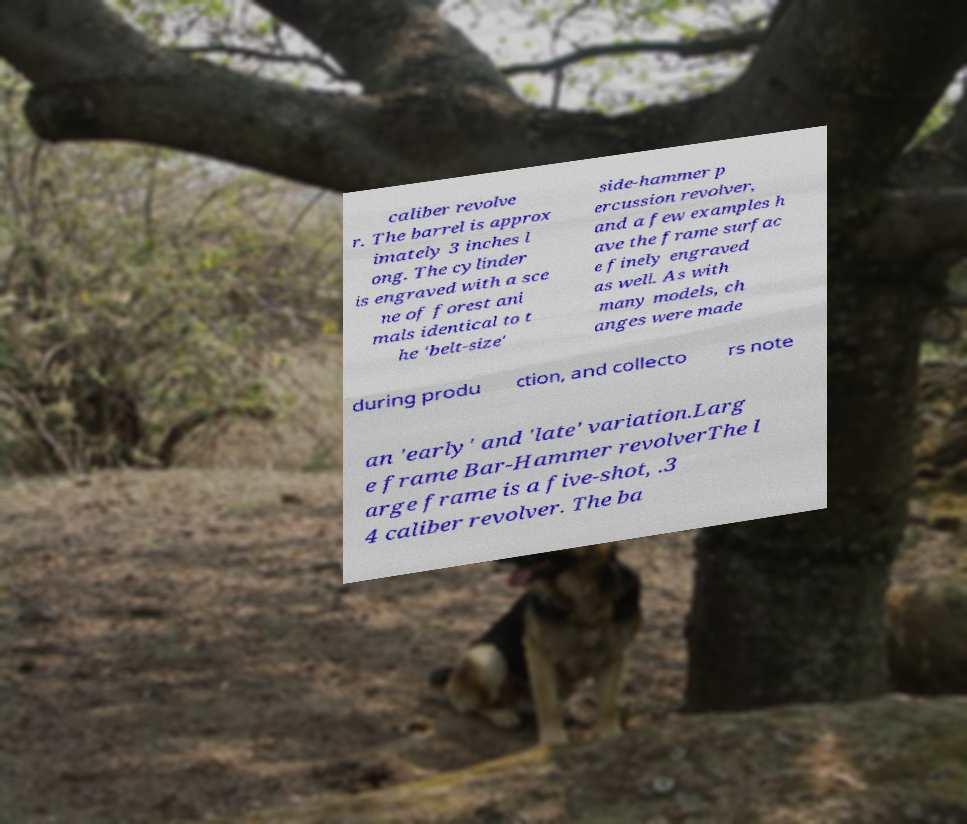Can you read and provide the text displayed in the image?This photo seems to have some interesting text. Can you extract and type it out for me? caliber revolve r. The barrel is approx imately 3 inches l ong. The cylinder is engraved with a sce ne of forest ani mals identical to t he 'belt-size' side-hammer p ercussion revolver, and a few examples h ave the frame surfac e finely engraved as well. As with many models, ch anges were made during produ ction, and collecto rs note an 'early' and 'late' variation.Larg e frame Bar-Hammer revolverThe l arge frame is a five-shot, .3 4 caliber revolver. The ba 